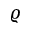Convert formula to latex. <formula><loc_0><loc_0><loc_500><loc_500>\varrho</formula> 